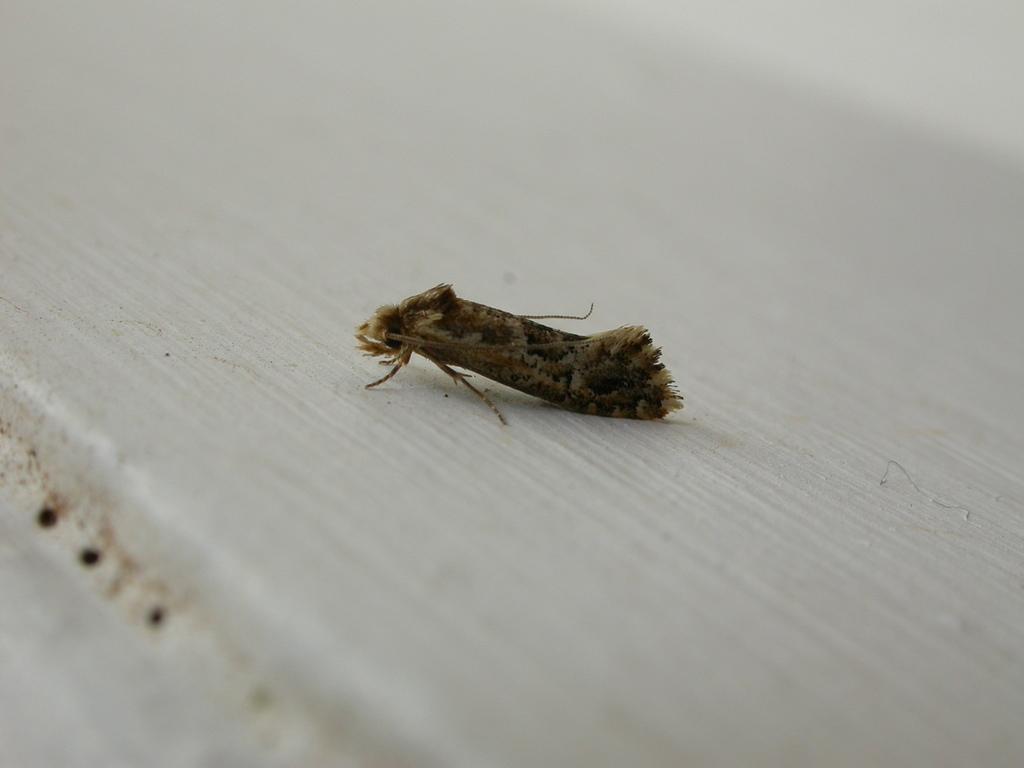How would you summarize this image in a sentence or two? In this image there is an insect on the surface. 